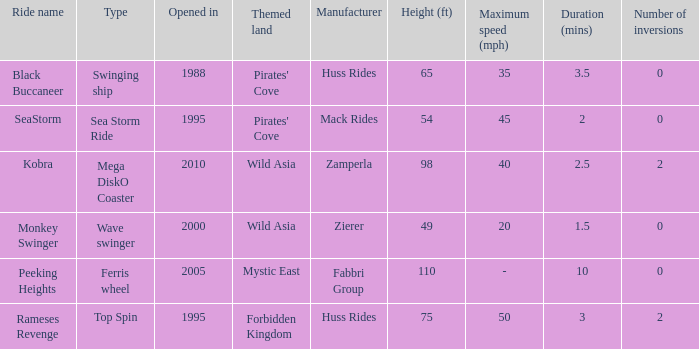What type ride is Wild Asia that opened in 2000? Wave swinger. 